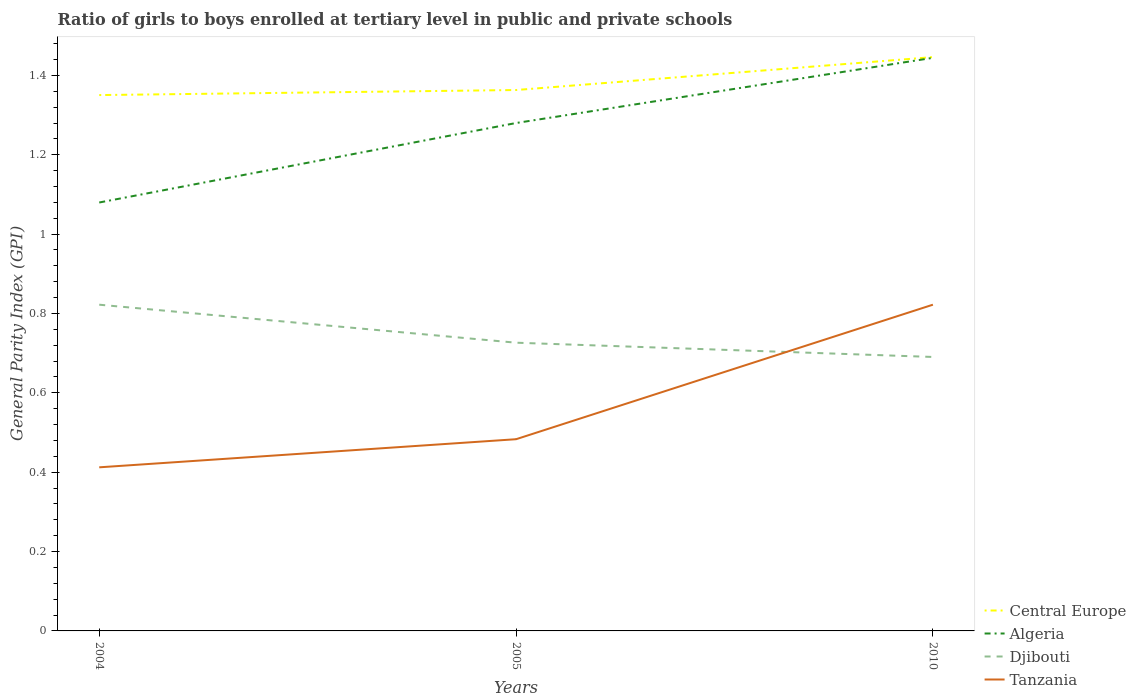Does the line corresponding to Djibouti intersect with the line corresponding to Tanzania?
Keep it short and to the point. Yes. Is the number of lines equal to the number of legend labels?
Offer a very short reply. Yes. Across all years, what is the maximum general parity index in Algeria?
Make the answer very short. 1.08. In which year was the general parity index in Tanzania maximum?
Your answer should be compact. 2004. What is the total general parity index in Algeria in the graph?
Offer a very short reply. -0.2. What is the difference between the highest and the second highest general parity index in Djibouti?
Provide a short and direct response. 0.13. Is the general parity index in Algeria strictly greater than the general parity index in Central Europe over the years?
Keep it short and to the point. Yes. How many lines are there?
Provide a short and direct response. 4. How many years are there in the graph?
Your answer should be very brief. 3. What is the difference between two consecutive major ticks on the Y-axis?
Your answer should be compact. 0.2. Does the graph contain grids?
Your answer should be very brief. No. How are the legend labels stacked?
Offer a very short reply. Vertical. What is the title of the graph?
Ensure brevity in your answer.  Ratio of girls to boys enrolled at tertiary level in public and private schools. Does "Mauritania" appear as one of the legend labels in the graph?
Your answer should be very brief. No. What is the label or title of the Y-axis?
Ensure brevity in your answer.  General Parity Index (GPI). What is the General Parity Index (GPI) in Central Europe in 2004?
Your answer should be compact. 1.35. What is the General Parity Index (GPI) of Algeria in 2004?
Your response must be concise. 1.08. What is the General Parity Index (GPI) of Djibouti in 2004?
Offer a very short reply. 0.82. What is the General Parity Index (GPI) of Tanzania in 2004?
Your answer should be very brief. 0.41. What is the General Parity Index (GPI) of Central Europe in 2005?
Provide a short and direct response. 1.36. What is the General Parity Index (GPI) in Algeria in 2005?
Provide a succinct answer. 1.28. What is the General Parity Index (GPI) in Djibouti in 2005?
Make the answer very short. 0.73. What is the General Parity Index (GPI) in Tanzania in 2005?
Give a very brief answer. 0.48. What is the General Parity Index (GPI) of Central Europe in 2010?
Make the answer very short. 1.45. What is the General Parity Index (GPI) in Algeria in 2010?
Provide a short and direct response. 1.44. What is the General Parity Index (GPI) of Djibouti in 2010?
Provide a succinct answer. 0.69. What is the General Parity Index (GPI) in Tanzania in 2010?
Make the answer very short. 0.82. Across all years, what is the maximum General Parity Index (GPI) in Central Europe?
Your answer should be compact. 1.45. Across all years, what is the maximum General Parity Index (GPI) of Algeria?
Your answer should be very brief. 1.44. Across all years, what is the maximum General Parity Index (GPI) in Djibouti?
Offer a terse response. 0.82. Across all years, what is the maximum General Parity Index (GPI) in Tanzania?
Your response must be concise. 0.82. Across all years, what is the minimum General Parity Index (GPI) in Central Europe?
Provide a short and direct response. 1.35. Across all years, what is the minimum General Parity Index (GPI) in Algeria?
Ensure brevity in your answer.  1.08. Across all years, what is the minimum General Parity Index (GPI) of Djibouti?
Your response must be concise. 0.69. Across all years, what is the minimum General Parity Index (GPI) in Tanzania?
Provide a succinct answer. 0.41. What is the total General Parity Index (GPI) of Central Europe in the graph?
Your answer should be very brief. 4.16. What is the total General Parity Index (GPI) of Algeria in the graph?
Your answer should be very brief. 3.8. What is the total General Parity Index (GPI) in Djibouti in the graph?
Provide a short and direct response. 2.24. What is the total General Parity Index (GPI) of Tanzania in the graph?
Your answer should be compact. 1.72. What is the difference between the General Parity Index (GPI) in Central Europe in 2004 and that in 2005?
Give a very brief answer. -0.01. What is the difference between the General Parity Index (GPI) of Algeria in 2004 and that in 2005?
Keep it short and to the point. -0.2. What is the difference between the General Parity Index (GPI) in Djibouti in 2004 and that in 2005?
Provide a short and direct response. 0.1. What is the difference between the General Parity Index (GPI) in Tanzania in 2004 and that in 2005?
Make the answer very short. -0.07. What is the difference between the General Parity Index (GPI) in Central Europe in 2004 and that in 2010?
Make the answer very short. -0.1. What is the difference between the General Parity Index (GPI) in Algeria in 2004 and that in 2010?
Provide a succinct answer. -0.36. What is the difference between the General Parity Index (GPI) of Djibouti in 2004 and that in 2010?
Your answer should be very brief. 0.13. What is the difference between the General Parity Index (GPI) in Tanzania in 2004 and that in 2010?
Ensure brevity in your answer.  -0.41. What is the difference between the General Parity Index (GPI) of Central Europe in 2005 and that in 2010?
Keep it short and to the point. -0.08. What is the difference between the General Parity Index (GPI) of Algeria in 2005 and that in 2010?
Make the answer very short. -0.16. What is the difference between the General Parity Index (GPI) in Djibouti in 2005 and that in 2010?
Your answer should be very brief. 0.04. What is the difference between the General Parity Index (GPI) of Tanzania in 2005 and that in 2010?
Offer a very short reply. -0.34. What is the difference between the General Parity Index (GPI) of Central Europe in 2004 and the General Parity Index (GPI) of Algeria in 2005?
Your response must be concise. 0.07. What is the difference between the General Parity Index (GPI) of Central Europe in 2004 and the General Parity Index (GPI) of Djibouti in 2005?
Provide a short and direct response. 0.62. What is the difference between the General Parity Index (GPI) of Central Europe in 2004 and the General Parity Index (GPI) of Tanzania in 2005?
Offer a very short reply. 0.87. What is the difference between the General Parity Index (GPI) in Algeria in 2004 and the General Parity Index (GPI) in Djibouti in 2005?
Provide a succinct answer. 0.35. What is the difference between the General Parity Index (GPI) of Algeria in 2004 and the General Parity Index (GPI) of Tanzania in 2005?
Your answer should be very brief. 0.6. What is the difference between the General Parity Index (GPI) of Djibouti in 2004 and the General Parity Index (GPI) of Tanzania in 2005?
Ensure brevity in your answer.  0.34. What is the difference between the General Parity Index (GPI) of Central Europe in 2004 and the General Parity Index (GPI) of Algeria in 2010?
Ensure brevity in your answer.  -0.09. What is the difference between the General Parity Index (GPI) in Central Europe in 2004 and the General Parity Index (GPI) in Djibouti in 2010?
Your response must be concise. 0.66. What is the difference between the General Parity Index (GPI) in Central Europe in 2004 and the General Parity Index (GPI) in Tanzania in 2010?
Keep it short and to the point. 0.53. What is the difference between the General Parity Index (GPI) of Algeria in 2004 and the General Parity Index (GPI) of Djibouti in 2010?
Keep it short and to the point. 0.39. What is the difference between the General Parity Index (GPI) in Algeria in 2004 and the General Parity Index (GPI) in Tanzania in 2010?
Offer a terse response. 0.26. What is the difference between the General Parity Index (GPI) of Djibouti in 2004 and the General Parity Index (GPI) of Tanzania in 2010?
Offer a terse response. -0. What is the difference between the General Parity Index (GPI) of Central Europe in 2005 and the General Parity Index (GPI) of Algeria in 2010?
Offer a terse response. -0.08. What is the difference between the General Parity Index (GPI) in Central Europe in 2005 and the General Parity Index (GPI) in Djibouti in 2010?
Your response must be concise. 0.67. What is the difference between the General Parity Index (GPI) in Central Europe in 2005 and the General Parity Index (GPI) in Tanzania in 2010?
Offer a very short reply. 0.54. What is the difference between the General Parity Index (GPI) in Algeria in 2005 and the General Parity Index (GPI) in Djibouti in 2010?
Provide a short and direct response. 0.59. What is the difference between the General Parity Index (GPI) of Algeria in 2005 and the General Parity Index (GPI) of Tanzania in 2010?
Your answer should be very brief. 0.46. What is the difference between the General Parity Index (GPI) in Djibouti in 2005 and the General Parity Index (GPI) in Tanzania in 2010?
Provide a succinct answer. -0.1. What is the average General Parity Index (GPI) in Central Europe per year?
Provide a short and direct response. 1.39. What is the average General Parity Index (GPI) of Algeria per year?
Your answer should be very brief. 1.27. What is the average General Parity Index (GPI) in Djibouti per year?
Provide a succinct answer. 0.75. What is the average General Parity Index (GPI) in Tanzania per year?
Give a very brief answer. 0.57. In the year 2004, what is the difference between the General Parity Index (GPI) in Central Europe and General Parity Index (GPI) in Algeria?
Your answer should be compact. 0.27. In the year 2004, what is the difference between the General Parity Index (GPI) in Central Europe and General Parity Index (GPI) in Djibouti?
Provide a succinct answer. 0.53. In the year 2004, what is the difference between the General Parity Index (GPI) in Central Europe and General Parity Index (GPI) in Tanzania?
Your response must be concise. 0.94. In the year 2004, what is the difference between the General Parity Index (GPI) in Algeria and General Parity Index (GPI) in Djibouti?
Give a very brief answer. 0.26. In the year 2004, what is the difference between the General Parity Index (GPI) of Algeria and General Parity Index (GPI) of Tanzania?
Keep it short and to the point. 0.67. In the year 2004, what is the difference between the General Parity Index (GPI) of Djibouti and General Parity Index (GPI) of Tanzania?
Provide a succinct answer. 0.41. In the year 2005, what is the difference between the General Parity Index (GPI) in Central Europe and General Parity Index (GPI) in Algeria?
Offer a very short reply. 0.08. In the year 2005, what is the difference between the General Parity Index (GPI) of Central Europe and General Parity Index (GPI) of Djibouti?
Your response must be concise. 0.64. In the year 2005, what is the difference between the General Parity Index (GPI) in Algeria and General Parity Index (GPI) in Djibouti?
Offer a terse response. 0.55. In the year 2005, what is the difference between the General Parity Index (GPI) of Algeria and General Parity Index (GPI) of Tanzania?
Your answer should be compact. 0.8. In the year 2005, what is the difference between the General Parity Index (GPI) of Djibouti and General Parity Index (GPI) of Tanzania?
Provide a short and direct response. 0.24. In the year 2010, what is the difference between the General Parity Index (GPI) of Central Europe and General Parity Index (GPI) of Algeria?
Give a very brief answer. 0. In the year 2010, what is the difference between the General Parity Index (GPI) of Central Europe and General Parity Index (GPI) of Djibouti?
Keep it short and to the point. 0.76. In the year 2010, what is the difference between the General Parity Index (GPI) of Central Europe and General Parity Index (GPI) of Tanzania?
Provide a short and direct response. 0.62. In the year 2010, what is the difference between the General Parity Index (GPI) of Algeria and General Parity Index (GPI) of Djibouti?
Your answer should be very brief. 0.75. In the year 2010, what is the difference between the General Parity Index (GPI) in Algeria and General Parity Index (GPI) in Tanzania?
Your response must be concise. 0.62. In the year 2010, what is the difference between the General Parity Index (GPI) in Djibouti and General Parity Index (GPI) in Tanzania?
Give a very brief answer. -0.13. What is the ratio of the General Parity Index (GPI) of Algeria in 2004 to that in 2005?
Your answer should be very brief. 0.84. What is the ratio of the General Parity Index (GPI) of Djibouti in 2004 to that in 2005?
Your answer should be compact. 1.13. What is the ratio of the General Parity Index (GPI) in Tanzania in 2004 to that in 2005?
Make the answer very short. 0.85. What is the ratio of the General Parity Index (GPI) in Central Europe in 2004 to that in 2010?
Your answer should be very brief. 0.93. What is the ratio of the General Parity Index (GPI) of Algeria in 2004 to that in 2010?
Your answer should be compact. 0.75. What is the ratio of the General Parity Index (GPI) of Djibouti in 2004 to that in 2010?
Your answer should be compact. 1.19. What is the ratio of the General Parity Index (GPI) of Tanzania in 2004 to that in 2010?
Ensure brevity in your answer.  0.5. What is the ratio of the General Parity Index (GPI) of Central Europe in 2005 to that in 2010?
Your answer should be very brief. 0.94. What is the ratio of the General Parity Index (GPI) of Algeria in 2005 to that in 2010?
Your answer should be very brief. 0.89. What is the ratio of the General Parity Index (GPI) of Djibouti in 2005 to that in 2010?
Your answer should be very brief. 1.05. What is the ratio of the General Parity Index (GPI) of Tanzania in 2005 to that in 2010?
Provide a short and direct response. 0.59. What is the difference between the highest and the second highest General Parity Index (GPI) in Central Europe?
Your answer should be very brief. 0.08. What is the difference between the highest and the second highest General Parity Index (GPI) of Algeria?
Make the answer very short. 0.16. What is the difference between the highest and the second highest General Parity Index (GPI) in Djibouti?
Give a very brief answer. 0.1. What is the difference between the highest and the second highest General Parity Index (GPI) in Tanzania?
Ensure brevity in your answer.  0.34. What is the difference between the highest and the lowest General Parity Index (GPI) of Central Europe?
Offer a very short reply. 0.1. What is the difference between the highest and the lowest General Parity Index (GPI) of Algeria?
Your response must be concise. 0.36. What is the difference between the highest and the lowest General Parity Index (GPI) of Djibouti?
Your response must be concise. 0.13. What is the difference between the highest and the lowest General Parity Index (GPI) in Tanzania?
Provide a succinct answer. 0.41. 